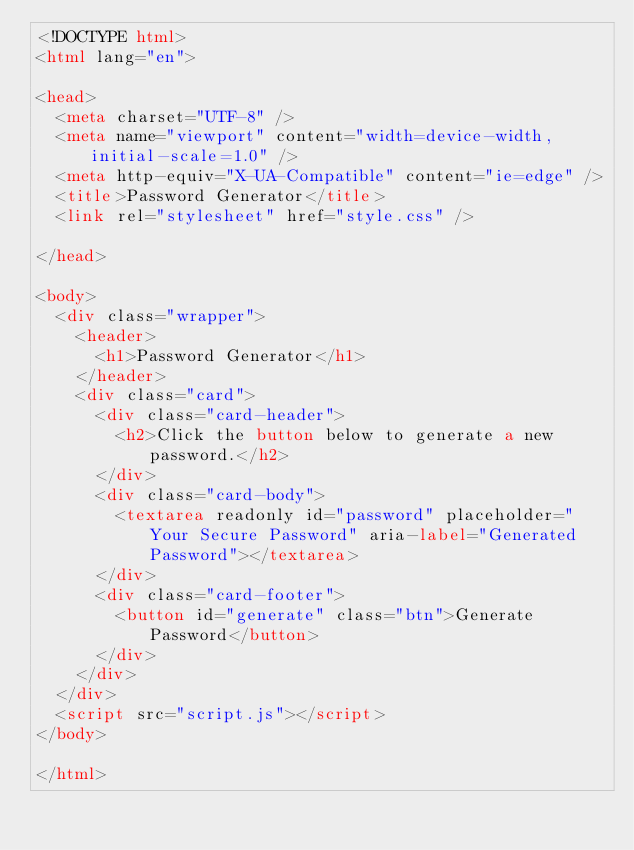Convert code to text. <code><loc_0><loc_0><loc_500><loc_500><_HTML_><!DOCTYPE html>
<html lang="en">

<head>
  <meta charset="UTF-8" />
  <meta name="viewport" content="width=device-width, initial-scale=1.0" />
  <meta http-equiv="X-UA-Compatible" content="ie=edge" />
  <title>Password Generator</title>
  <link rel="stylesheet" href="style.css" />

</head>

<body>
  <div class="wrapper">
    <header>
      <h1>Password Generator</h1>
    </header>
    <div class="card">
      <div class="card-header">
        <h2>Click the button below to generate a new password.</h2>
      </div>
      <div class="card-body">
        <textarea readonly id="password" placeholder="Your Secure Password" aria-label="Generated Password"></textarea>
      </div>
      <div class="card-footer">
        <button id="generate" class="btn">Generate Password</button>
      </div>
    </div>
  </div>
  <script src="script.js"></script>
</body>

</html></code> 